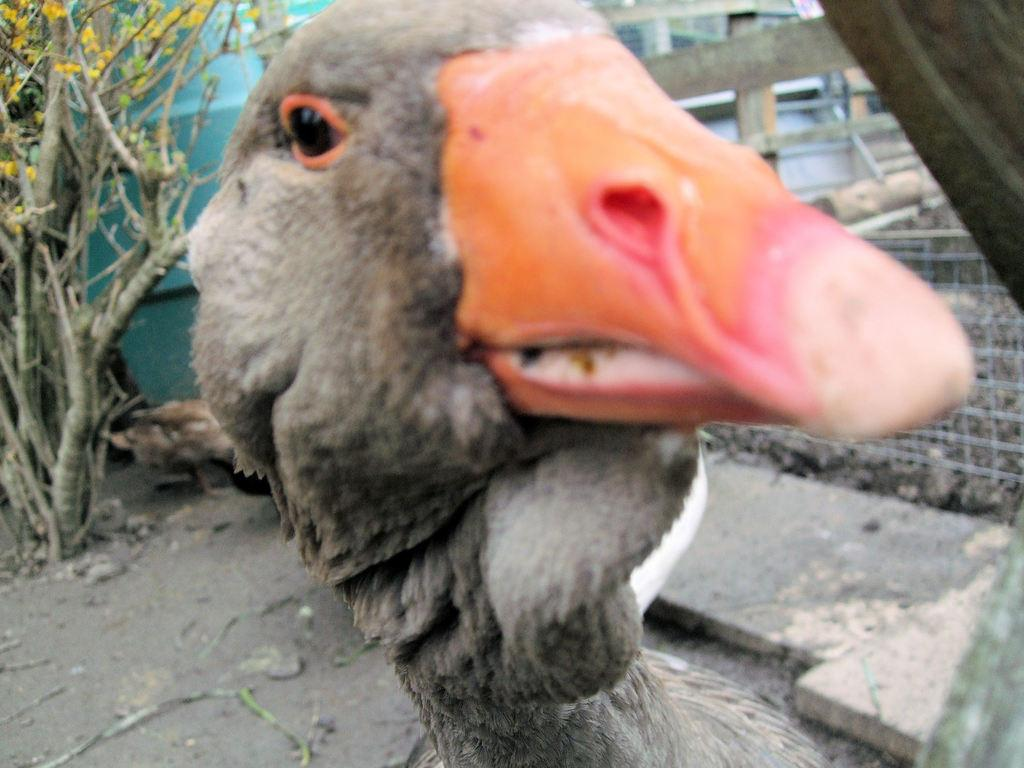What type of bird can be seen in the image? There is a grey color bird in the image. Where is the bird located in the image? The bird is in the front of the image. What can be seen in the background of the image? There is a plant, wooden poles, and fencing in the background of the image. What is on the ground in the image? There are sticks on the ground in the image. What type of holiday is being celebrated in the image? There is no indication of a holiday being celebrated in the image. What type of soda is the bird drinking in the image? There is no soda present in the image; it features a bird and various background elements. 